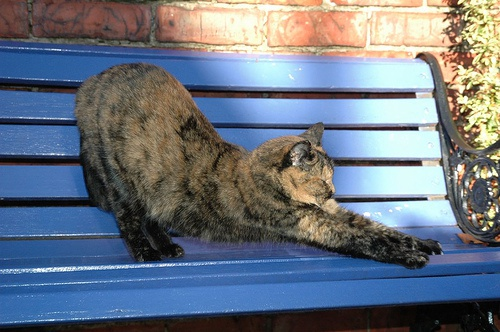Describe the objects in this image and their specific colors. I can see bench in brown, blue, gray, and lightblue tones and cat in brown, gray, and black tones in this image. 